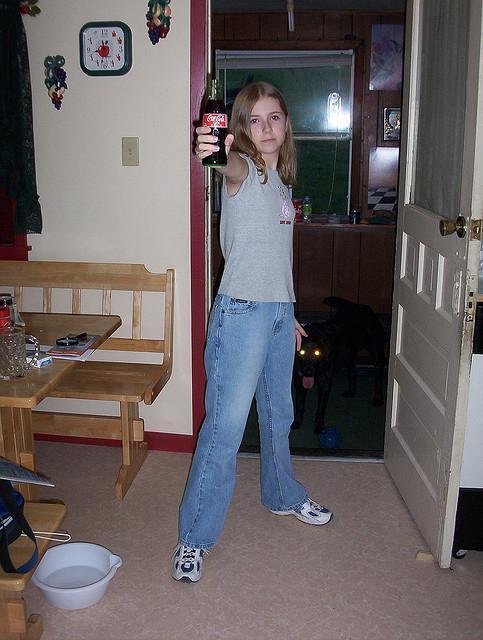Is this affirmation: "The person is touching the bowl." correct?
Answer yes or no. No. 